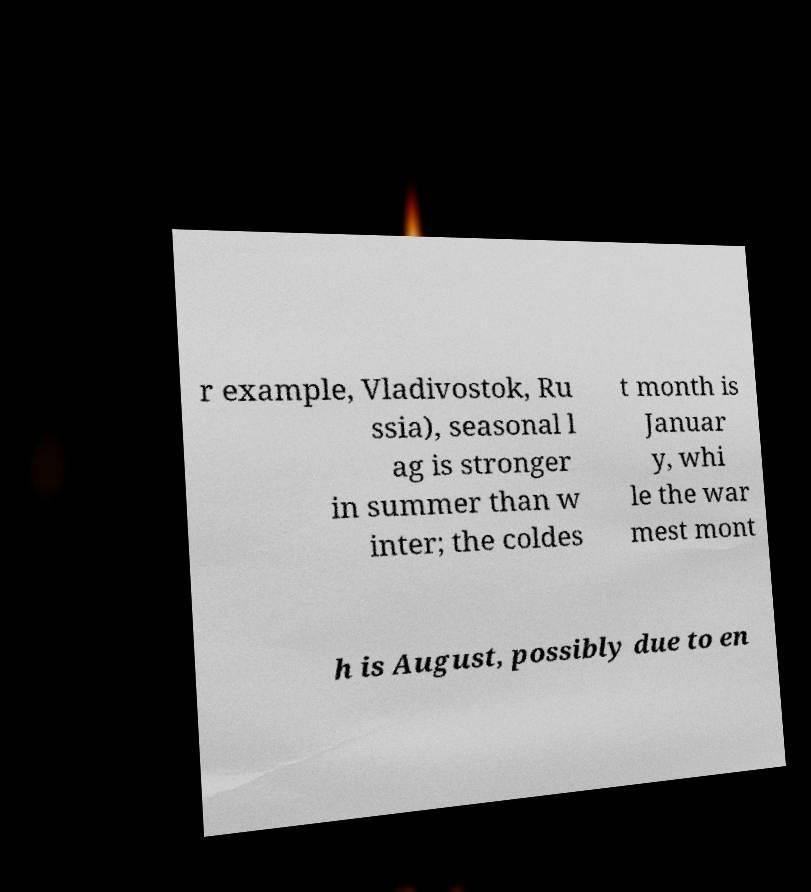There's text embedded in this image that I need extracted. Can you transcribe it verbatim? r example, Vladivostok, Ru ssia), seasonal l ag is stronger in summer than w inter; the coldes t month is Januar y, whi le the war mest mont h is August, possibly due to en 